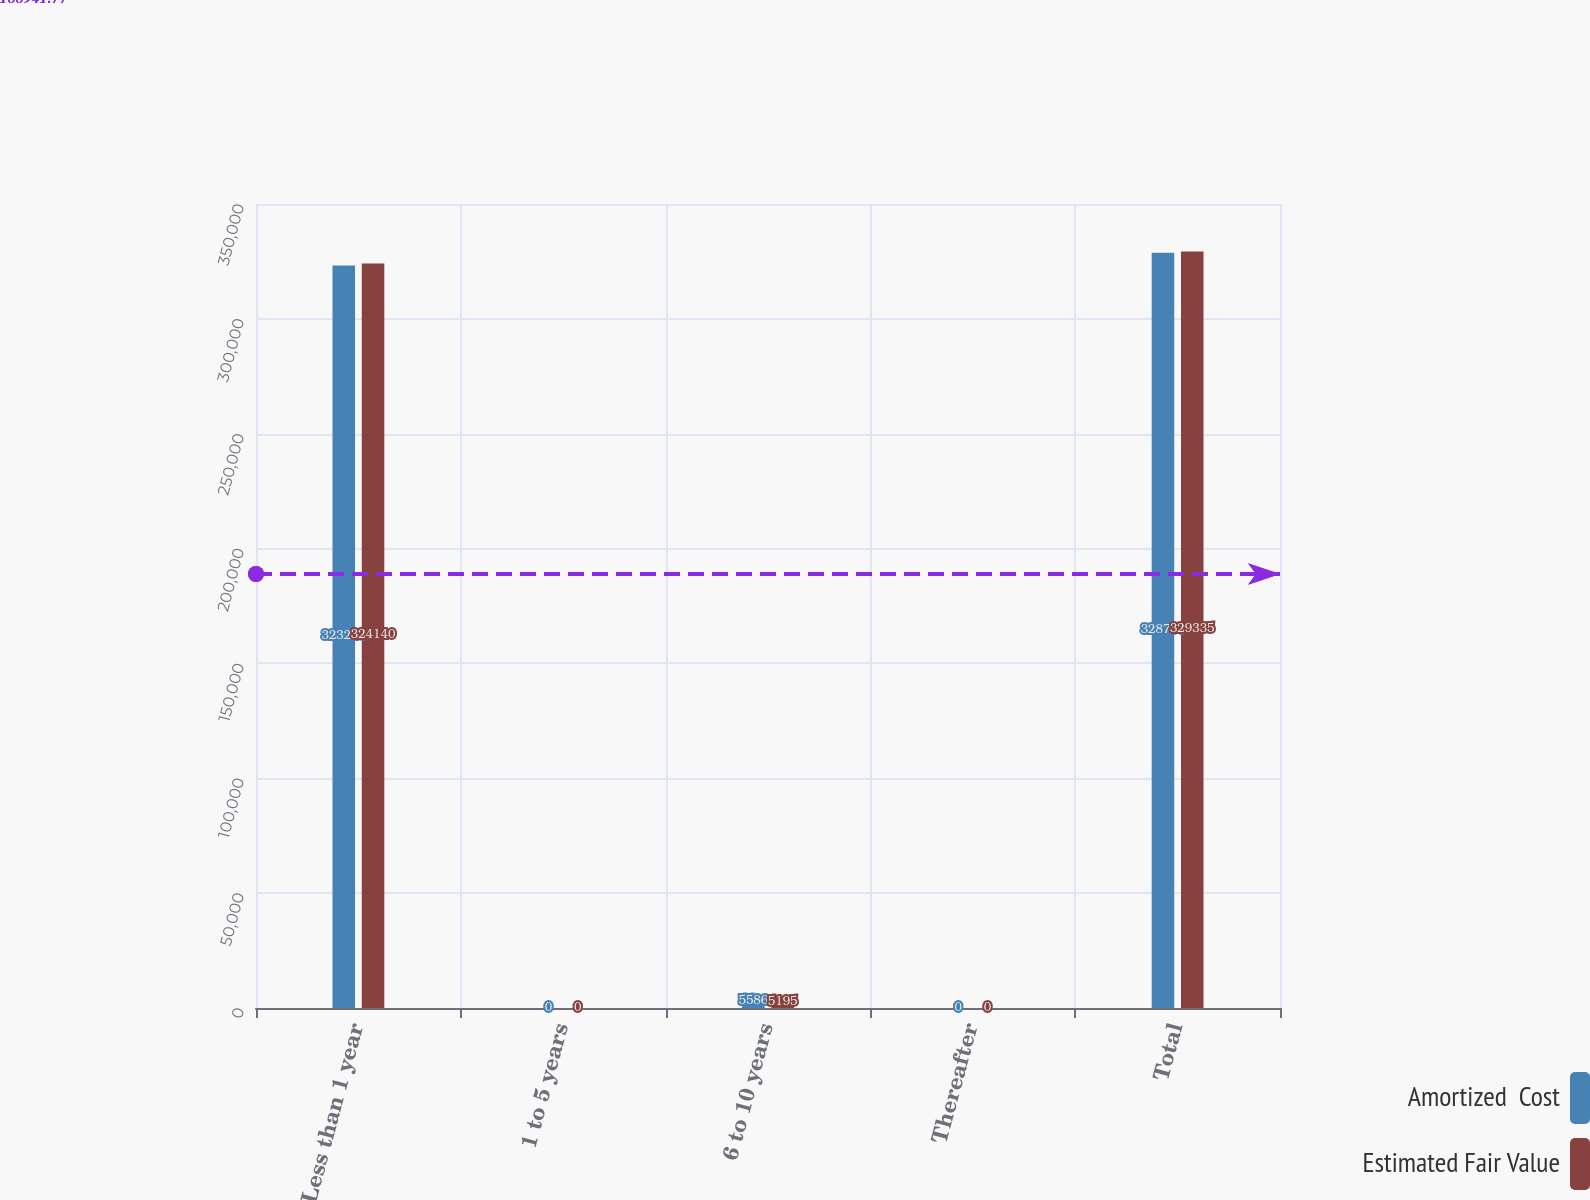Convert chart. <chart><loc_0><loc_0><loc_500><loc_500><stacked_bar_chart><ecel><fcel>Less than 1 year<fcel>1 to 5 years<fcel>6 to 10 years<fcel>Thereafter<fcel>Total<nl><fcel>Amortized  Cost<fcel>323210<fcel>0<fcel>5586<fcel>0<fcel>328796<nl><fcel>Estimated Fair Value<fcel>324140<fcel>0<fcel>5195<fcel>0<fcel>329335<nl></chart> 